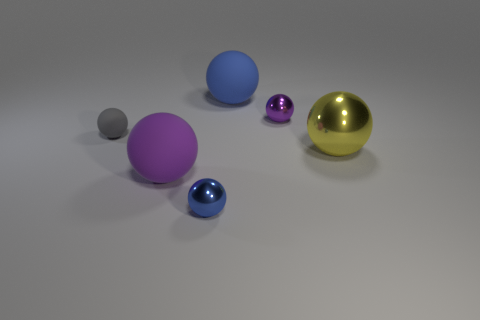Judging by their colors, which two balls might represent a clear sky and grass in a stylized landscape? The blue ball could represent the clear sky, and the small gray ball, although not green, could be interpreted as representing the earth or grass in a very stylized landscape, due to its position and contrast with the other colors in the scene. 